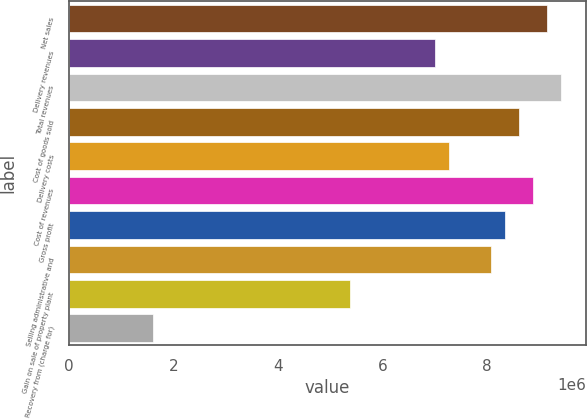Convert chart to OTSL. <chart><loc_0><loc_0><loc_500><loc_500><bar_chart><fcel>Net sales<fcel>Delivery revenues<fcel>Total revenues<fcel>Cost of goods sold<fcel>Delivery costs<fcel>Cost of revenues<fcel>Gross profit<fcel>Selling administrative and<fcel>Gain on sale of property plant<fcel>Recovery from (charge for)<nl><fcel>9.14767e+06<fcel>6.99527e+06<fcel>9.41671e+06<fcel>8.60957e+06<fcel>7.26432e+06<fcel>8.87862e+06<fcel>8.34052e+06<fcel>8.07147e+06<fcel>5.38098e+06<fcel>1.61429e+06<nl></chart> 